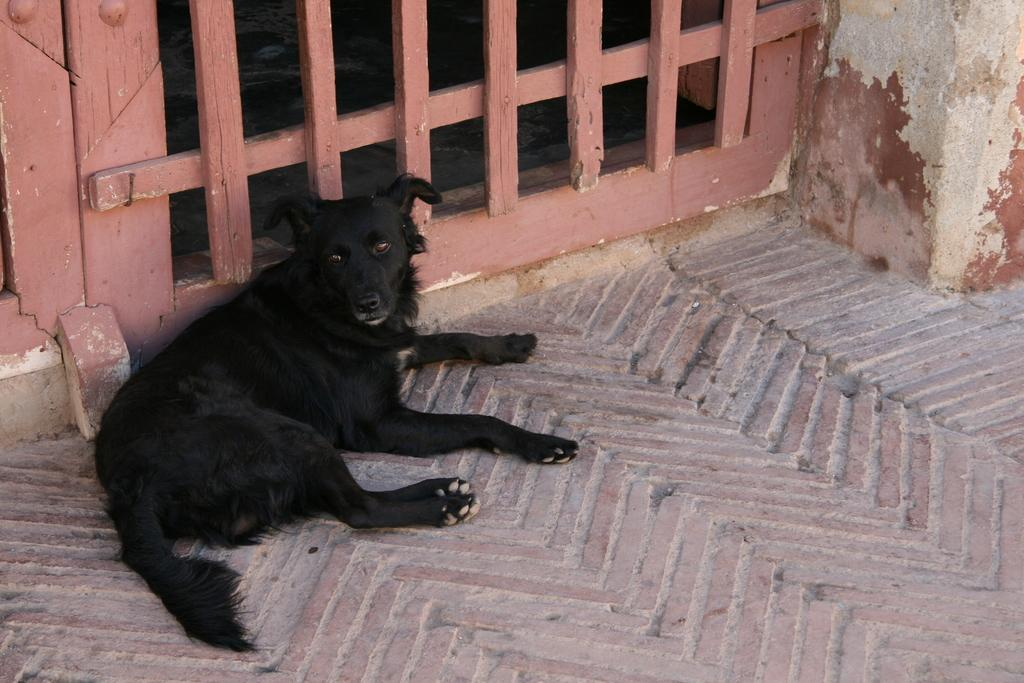What type of animal is in the image? There is a black dog in the image. Where is the dog located in the image? The dog is in the front of the image. What can be seen in the background of the image? There are wooden bars visible in the background of the image. What type of bread can be seen in the image? There is no bread present in the image; it features a black dog in the front and wooden bars in the background. 